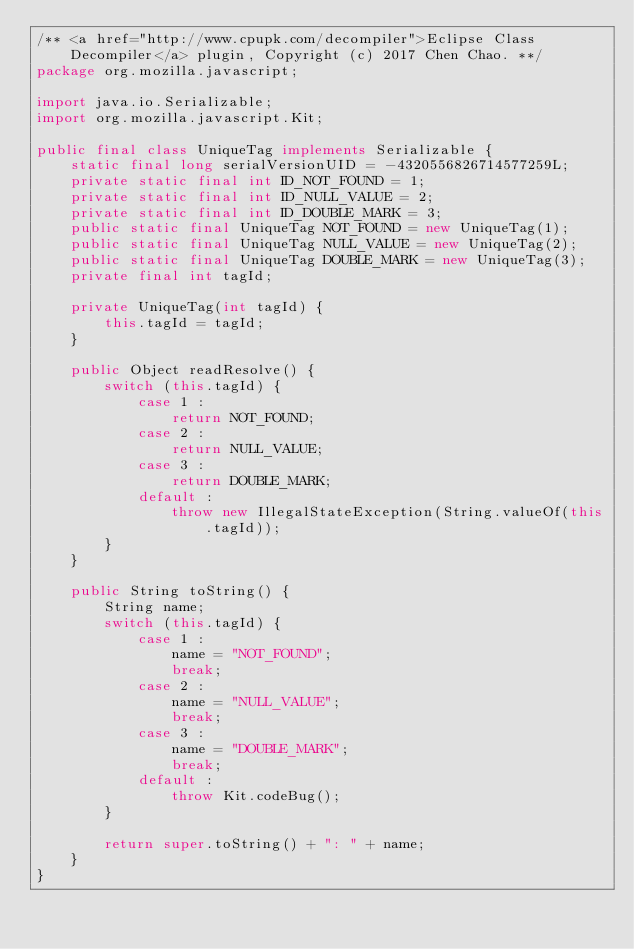<code> <loc_0><loc_0><loc_500><loc_500><_Java_>/** <a href="http://www.cpupk.com/decompiler">Eclipse Class Decompiler</a> plugin, Copyright (c) 2017 Chen Chao. **/
package org.mozilla.javascript;

import java.io.Serializable;
import org.mozilla.javascript.Kit;

public final class UniqueTag implements Serializable {
	static final long serialVersionUID = -4320556826714577259L;
	private static final int ID_NOT_FOUND = 1;
	private static final int ID_NULL_VALUE = 2;
	private static final int ID_DOUBLE_MARK = 3;
	public static final UniqueTag NOT_FOUND = new UniqueTag(1);
	public static final UniqueTag NULL_VALUE = new UniqueTag(2);
	public static final UniqueTag DOUBLE_MARK = new UniqueTag(3);
	private final int tagId;

	private UniqueTag(int tagId) {
		this.tagId = tagId;
	}

	public Object readResolve() {
		switch (this.tagId) {
			case 1 :
				return NOT_FOUND;
			case 2 :
				return NULL_VALUE;
			case 3 :
				return DOUBLE_MARK;
			default :
				throw new IllegalStateException(String.valueOf(this.tagId));
		}
	}

	public String toString() {
		String name;
		switch (this.tagId) {
			case 1 :
				name = "NOT_FOUND";
				break;
			case 2 :
				name = "NULL_VALUE";
				break;
			case 3 :
				name = "DOUBLE_MARK";
				break;
			default :
				throw Kit.codeBug();
		}

		return super.toString() + ": " + name;
	}
}</code> 